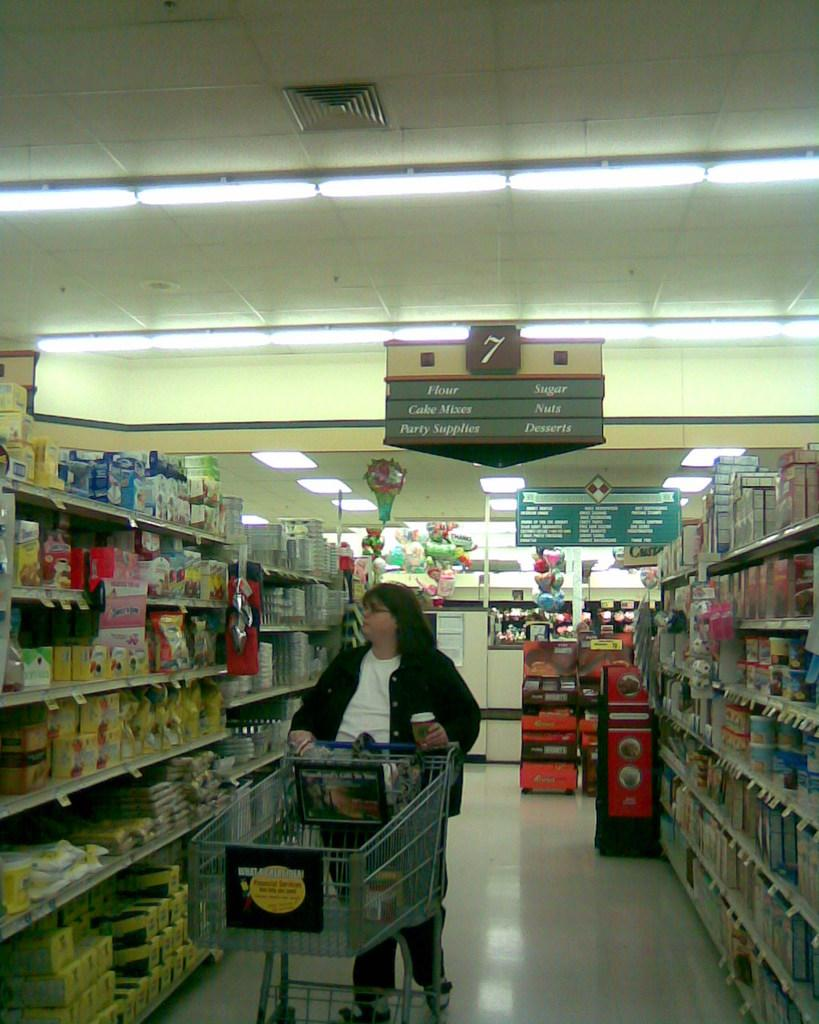<image>
Present a compact description of the photo's key features. A woman pushes a trolly in a supermarket below a sign that describes the aisle as a bakery section. 